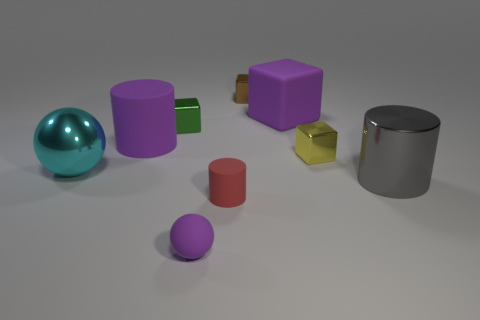Are there fewer shiny balls that are on the right side of the tiny sphere than big matte spheres?
Offer a very short reply. No. Are there any large rubber things of the same color as the large shiny sphere?
Keep it short and to the point. No. There is a tiny brown metallic object; does it have the same shape as the large shiny object left of the large matte cube?
Ensure brevity in your answer.  No. Is there a yellow thing that has the same material as the green cube?
Ensure brevity in your answer.  Yes. There is a big purple rubber thing that is to the right of the rubber cylinder that is in front of the purple matte cylinder; are there any large metal things that are on the left side of it?
Your answer should be compact. Yes. How many other objects are there of the same shape as the red matte thing?
Your answer should be very brief. 2. What is the color of the large metal object behind the large cylinder in front of the object that is to the left of the purple matte cylinder?
Your response must be concise. Cyan. How many small rubber objects are there?
Provide a succinct answer. 2. How many tiny things are either green things or yellow blocks?
Give a very brief answer. 2. There is a cyan thing that is the same size as the gray thing; what is its shape?
Ensure brevity in your answer.  Sphere. 